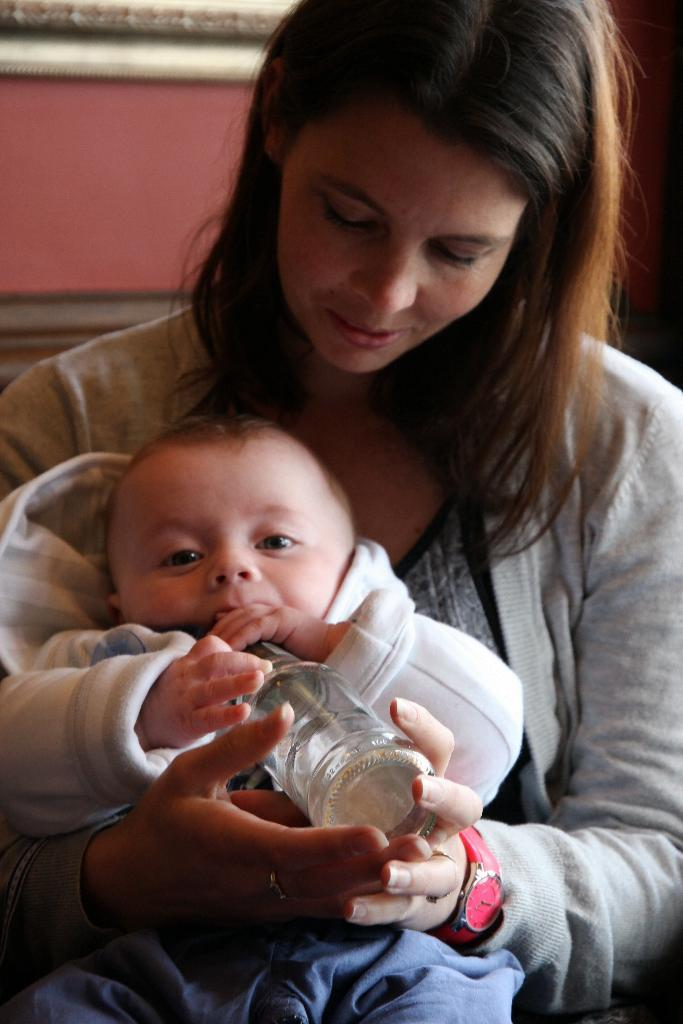Who is present in the image? There is a person in the image. What is the person wearing? The person is wearing clothes. What is the person holding in the image? The person is holding a baby and a bottle with her hands. What level of the building is the person standing on in the image? There is no information about a building or a specific level in the image; it only shows a person holding a baby and a bottle. 